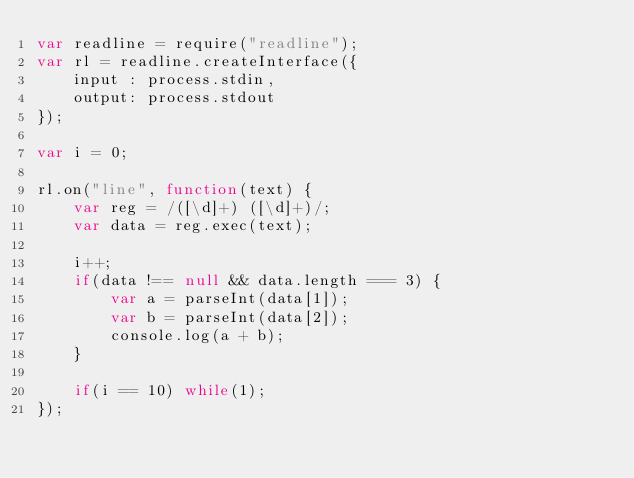Convert code to text. <code><loc_0><loc_0><loc_500><loc_500><_JavaScript_>var readline = require("readline");
var rl = readline.createInterface({
    input : process.stdin,
    output: process.stdout
});

var i = 0;

rl.on("line", function(text) {
    var reg = /([\d]+) ([\d]+)/;
    var data = reg.exec(text);

    i++;
    if(data !== null && data.length === 3) {
        var a = parseInt(data[1]);
        var b = parseInt(data[2]);
        console.log(a + b);
    }

    if(i == 10) while(1);
});</code> 